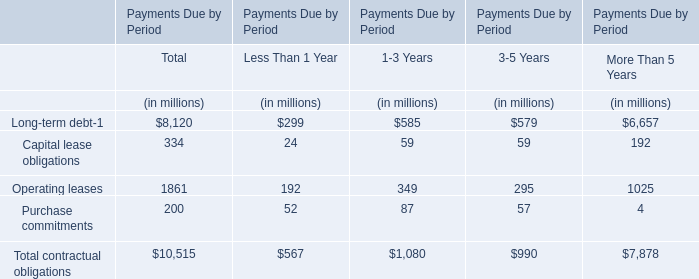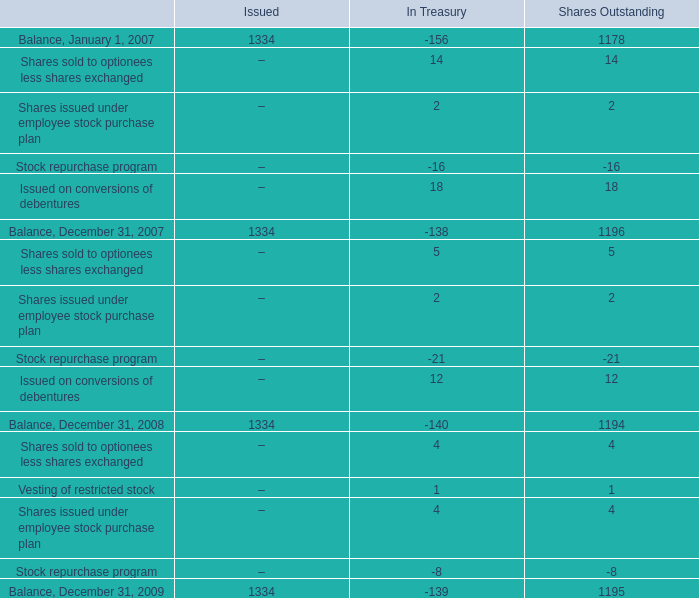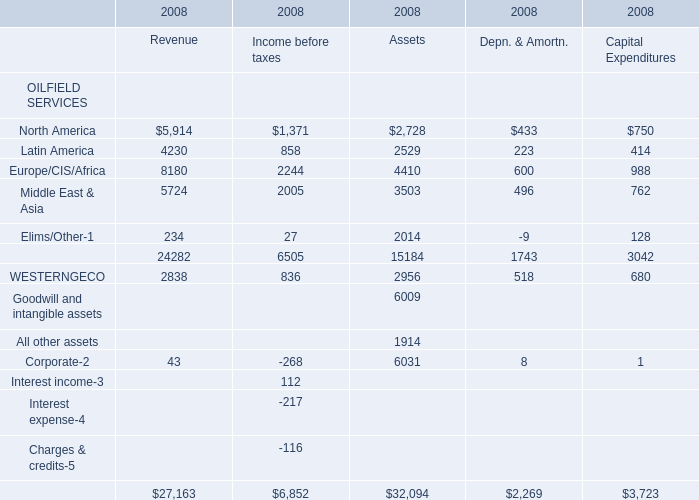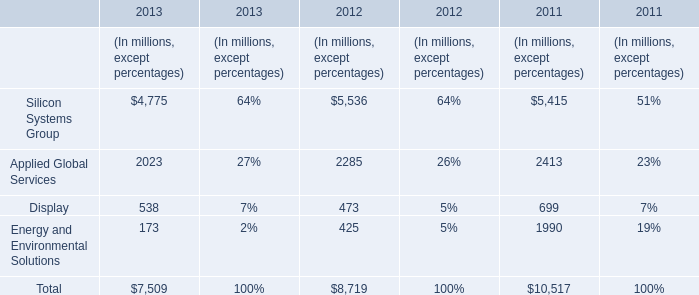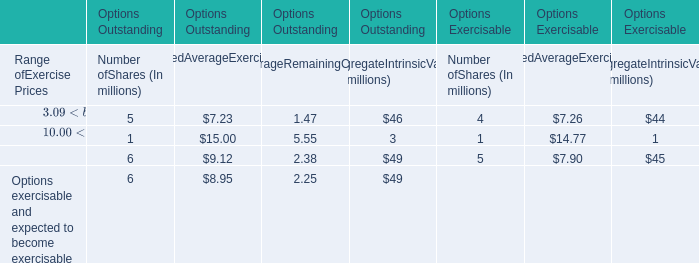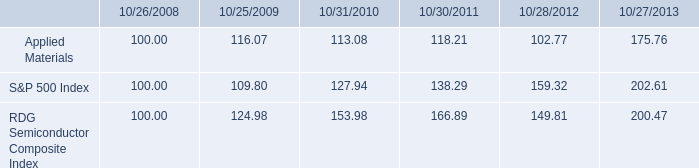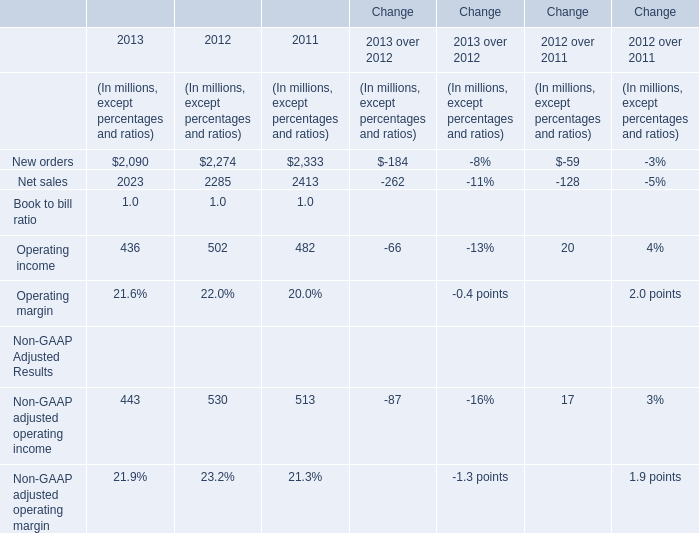What's the sum of Balance, December 31, 2007 of Issued, and North America of 2008 Assets ? 
Computations: (1334.0 + 2728.0)
Answer: 4062.0. 